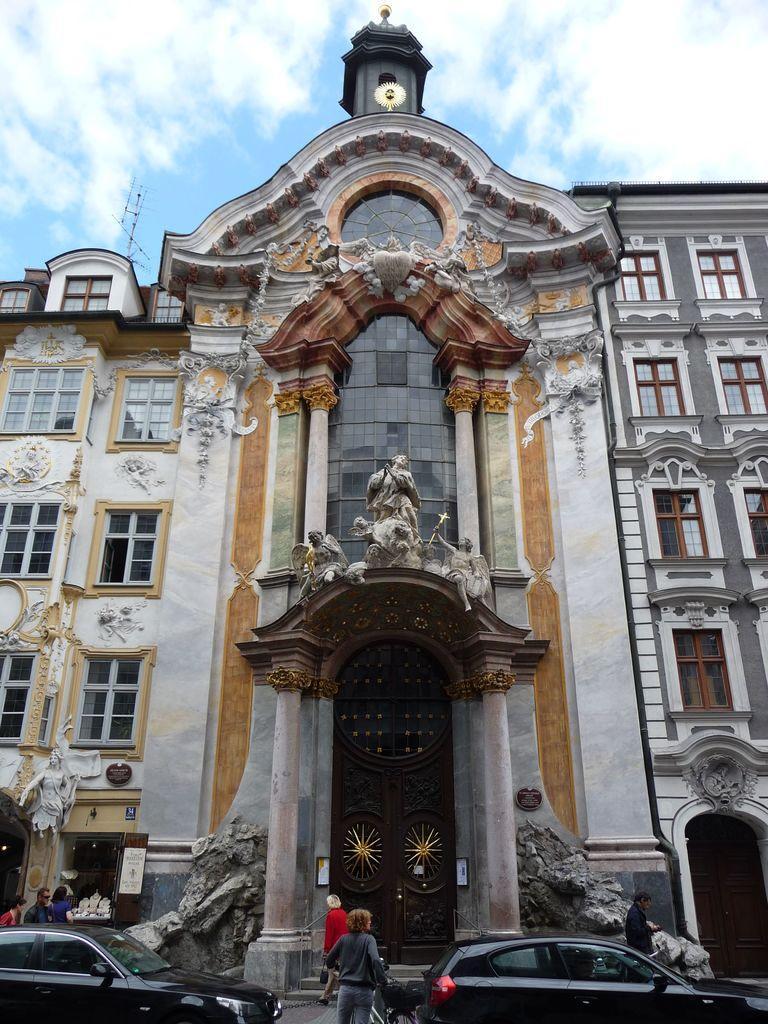Can you describe this image briefly? In this image I can see two person standing on the road. I can also see two vehicle they are in black color. Background I can see few persons standing, building in white and brown color, and sky is in blue and white color. 